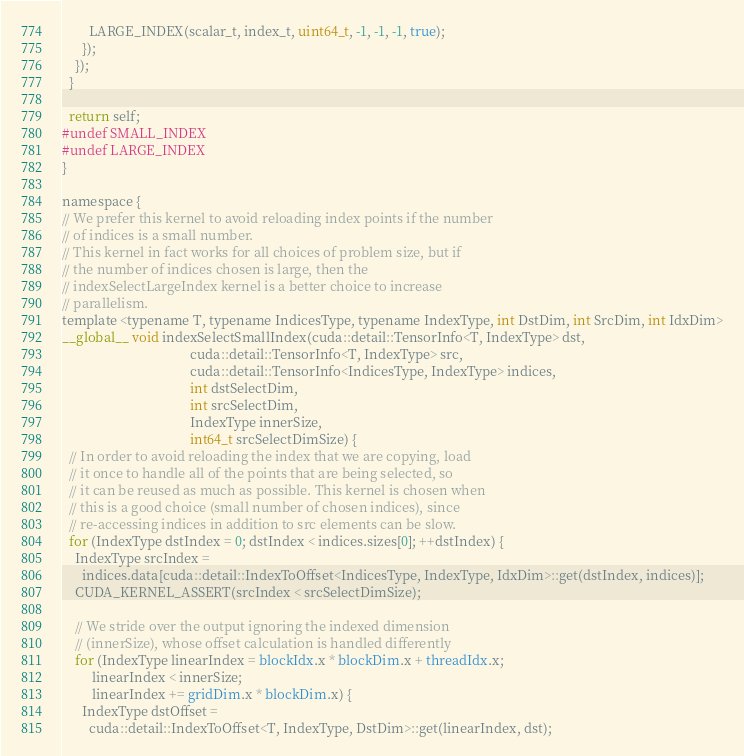<code> <loc_0><loc_0><loc_500><loc_500><_Cuda_>
        LARGE_INDEX(scalar_t, index_t, uint64_t, -1, -1, -1, true);
      });
    });
  }

  return self;
#undef SMALL_INDEX
#undef LARGE_INDEX
}

namespace {
// We prefer this kernel to avoid reloading index points if the number
// of indices is a small number.
// This kernel in fact works for all choices of problem size, but if
// the number of indices chosen is large, then the
// indexSelectLargeIndex kernel is a better choice to increase
// parallelism.
template <typename T, typename IndicesType, typename IndexType, int DstDim, int SrcDim, int IdxDim>
__global__ void indexSelectSmallIndex(cuda::detail::TensorInfo<T, IndexType> dst,
                                      cuda::detail::TensorInfo<T, IndexType> src,
                                      cuda::detail::TensorInfo<IndicesType, IndexType> indices,
                                      int dstSelectDim,
                                      int srcSelectDim,
                                      IndexType innerSize,
                                      int64_t srcSelectDimSize) {
  // In order to avoid reloading the index that we are copying, load
  // it once to handle all of the points that are being selected, so
  // it can be reused as much as possible. This kernel is chosen when
  // this is a good choice (small number of chosen indices), since
  // re-accessing indices in addition to src elements can be slow.
  for (IndexType dstIndex = 0; dstIndex < indices.sizes[0]; ++dstIndex) {
    IndexType srcIndex =
      indices.data[cuda::detail::IndexToOffset<IndicesType, IndexType, IdxDim>::get(dstIndex, indices)];
    CUDA_KERNEL_ASSERT(srcIndex < srcSelectDimSize);

    // We stride over the output ignoring the indexed dimension
    // (innerSize), whose offset calculation is handled differently
    for (IndexType linearIndex = blockIdx.x * blockDim.x + threadIdx.x;
         linearIndex < innerSize;
         linearIndex += gridDim.x * blockDim.x) {
      IndexType dstOffset =
        cuda::detail::IndexToOffset<T, IndexType, DstDim>::get(linearIndex, dst);</code> 